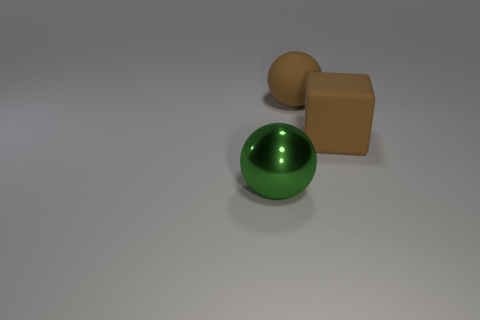The brown object that is the same size as the rubber block is what shape?
Ensure brevity in your answer.  Sphere. Is the thing to the right of the large matte sphere made of the same material as the brown thing behind the big brown rubber block?
Keep it short and to the point. Yes. Is there a ball that is right of the metal sphere left of the brown cube?
Provide a succinct answer. Yes. What is the color of the big object that is the same material as the big cube?
Your answer should be compact. Brown. Is the number of green things greater than the number of red spheres?
Your answer should be very brief. Yes. What number of objects are either large brown balls behind the large metal ball or rubber things?
Keep it short and to the point. 2. Are there any purple metal cylinders that have the same size as the matte cube?
Offer a very short reply. No. Are there fewer large brown objects than green metallic balls?
Give a very brief answer. No. What number of balls are brown objects or metallic things?
Your answer should be compact. 2. What number of other big rubber blocks are the same color as the big rubber block?
Offer a terse response. 0. 